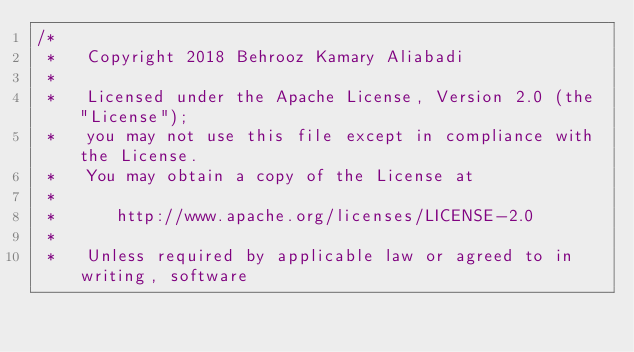<code> <loc_0><loc_0><loc_500><loc_500><_C++_>/*
 *   Copyright 2018 Behrooz Kamary Aliabadi
 *
 *   Licensed under the Apache License, Version 2.0 (the "License");
 *   you may not use this file except in compliance with the License.
 *   You may obtain a copy of the License at
 *
 *      http://www.apache.org/licenses/LICENSE-2.0
 *
 *   Unless required by applicable law or agreed to in writing, software</code> 